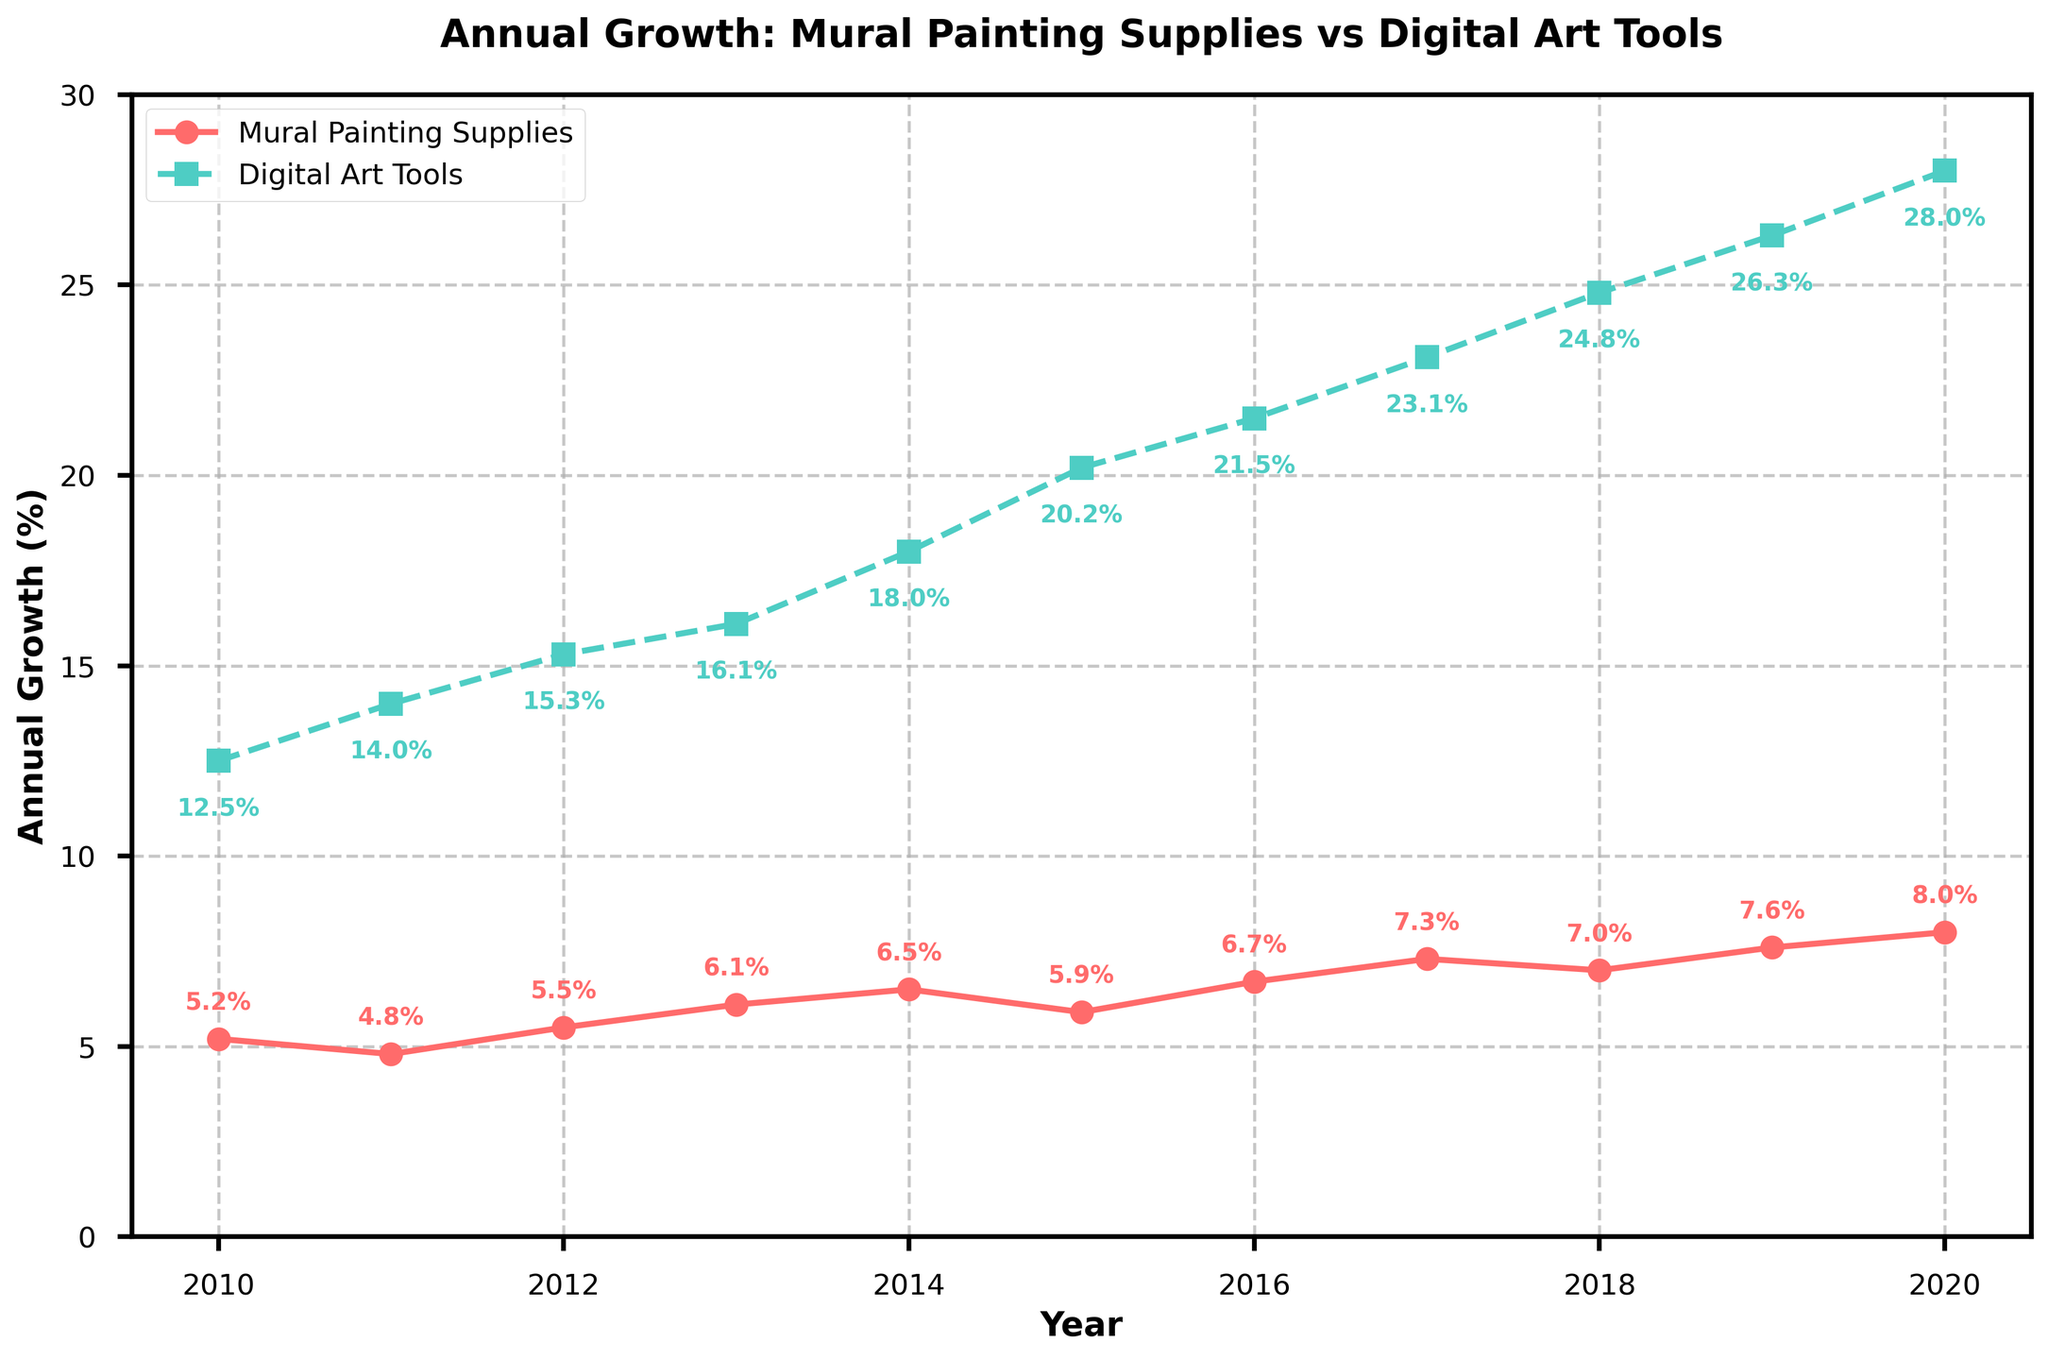What's the title of the plot? The title of the plot is shown at the top and reads "Annual Growth: Mural Painting Supplies vs Digital Art Tools".
Answer: Annual Growth: Mural Painting Supplies vs Digital Art Tools What color is used to represent mural painting supplies growth? The line representing mural painting supplies growth is colored in red.
Answer: Red In which year did mural painting supplies growth surpass 7%? The data point for mural painting supplies growth exceeding 7% appears in 2017.
Answer: 2017 What was the annual growth rate for digital art tools in 2015? The digital art tools growth rate is marked on the plot as 20.2% for the year 2015.
Answer: 20.2% What's the average growth rate of mural painting supplies from 2010 to 2020? Sum the growth rates from 2010 to 2020 (5.2 + 4.8 + 5.5 + 6.1 + 6.5 + 5.9 + 6.7 + 7.3 + 7.0 + 7.6 + 8.0) and divide by the number of years (11), which gives approximately 6.44%.
Answer: 6.44% How much did the digital art tools growth rate increase from 2010 to 2020? Subtract the growth rate of digital art tools in 2010 (12.5%) from the rate in 2020 (28.0%), which results in an increase of 15.5%.
Answer: 15.5% Which year had the highest annual growth rate for mural painting supplies? The highest annual growth rate for mural painting supplies is 8.0% in the year 2020.
Answer: 2020 By how much did the growth rate for digital art tools exceed the growth rate for mural painting supplies in 2014? Subtract the growth rate of mural painting supplies in 2014 (6.5%) from the growth rate of digital art tools in the same year (18%), which results in an excess of 11.5%.
Answer: 11.5% Which growth curve shows a consistently higher annual growth rate across all years? The plot shows that the digital art tools growth curve consistently has higher annual growth rates compared to the mural painting supplies at every data point from 2010 to 2020.
Answer: Digital art tools 